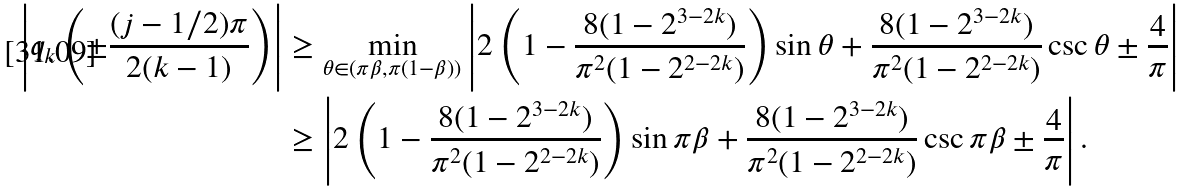<formula> <loc_0><loc_0><loc_500><loc_500>\left | q _ { k } \left ( \pm \frac { ( j - 1 / 2 ) \pi } { 2 ( k - 1 ) } \right ) \right | & \geq \min _ { \theta \in ( \pi \beta , \pi ( 1 - \beta ) ) } \left | 2 \left ( 1 - \frac { 8 ( 1 - 2 ^ { 3 - 2 k } ) } { \pi ^ { 2 } ( 1 - 2 ^ { 2 - 2 k } ) } \right ) \sin \theta + \frac { 8 ( 1 - 2 ^ { 3 - 2 k } ) } { \pi ^ { 2 } ( 1 - 2 ^ { 2 - 2 k } ) } \csc \theta \pm \frac { 4 } { \pi } \right | \\ & \geq \left | 2 \left ( 1 - \frac { 8 ( 1 - 2 ^ { 3 - 2 k } ) } { \pi ^ { 2 } ( 1 - 2 ^ { 2 - 2 k } ) } \right ) \sin \pi \beta + \frac { 8 ( 1 - 2 ^ { 3 - 2 k } ) } { \pi ^ { 2 } ( 1 - 2 ^ { 2 - 2 k } ) } \csc \pi \beta \pm \frac { 4 } { \pi } \right | .</formula> 